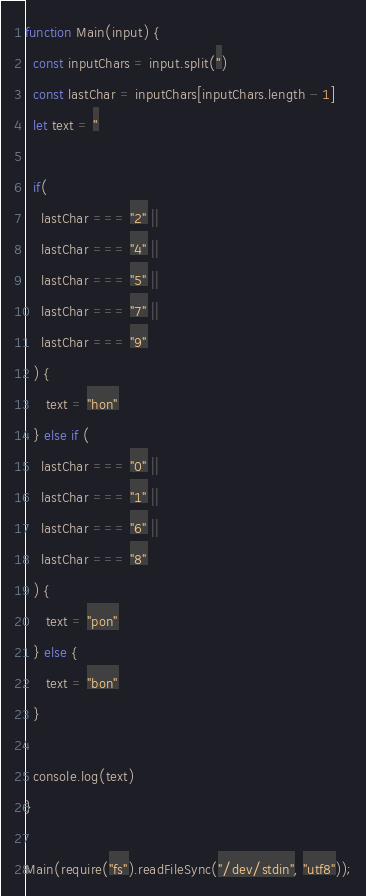<code> <loc_0><loc_0><loc_500><loc_500><_JavaScript_>function Main(input) {
  const inputChars = input.split('')
  const lastChar = inputChars[inputChars.length - 1]
  let text = ''
  
  if(
    lastChar === "2" ||
    lastChar === "4" ||
    lastChar === "5" ||
    lastChar === "7" ||
    lastChar === "9"
  ) {
     text = "hon"
  } else if (
    lastChar === "0" ||
    lastChar === "1" ||
    lastChar === "6" ||
    lastChar === "8"
  ) {
     text = "pon"     
  } else {
     text = "bon"
  }
  
  console.log(text)
}

Main(require("fs").readFileSync("/dev/stdin", "utf8"));</code> 